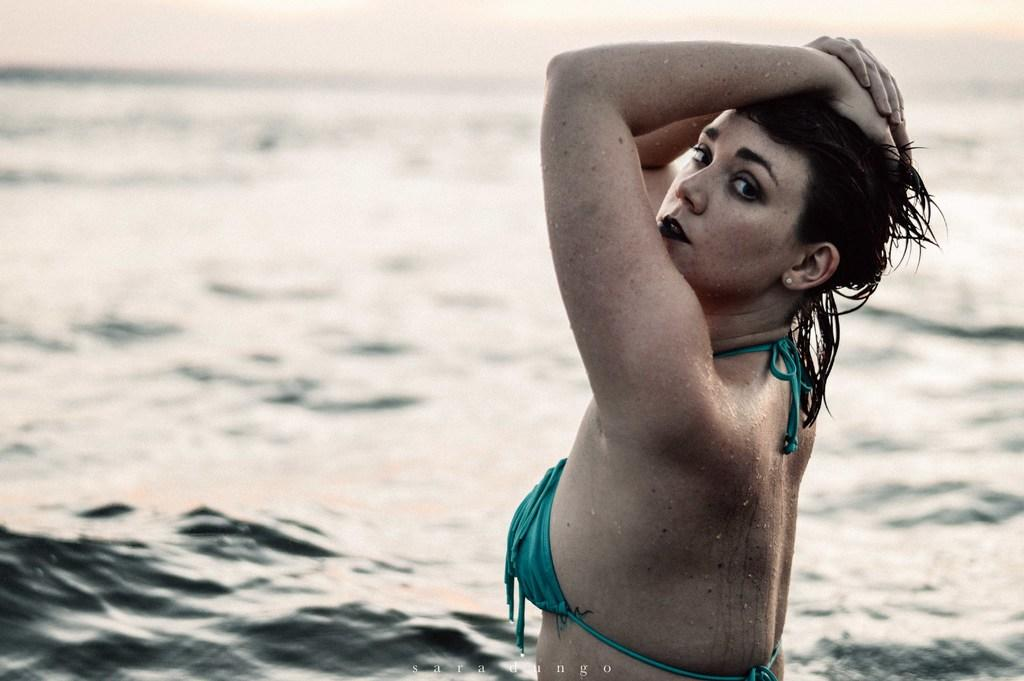Who is the main subject in the image? There is a lady in the image. What is visible in the background behind the lady? There is water visible behind the lady. Is there any text or label present in the image? Yes, there is a name at the bottom of the image. What type of thread is being used to create the flame in the image? There is no thread or flame present in the image. 